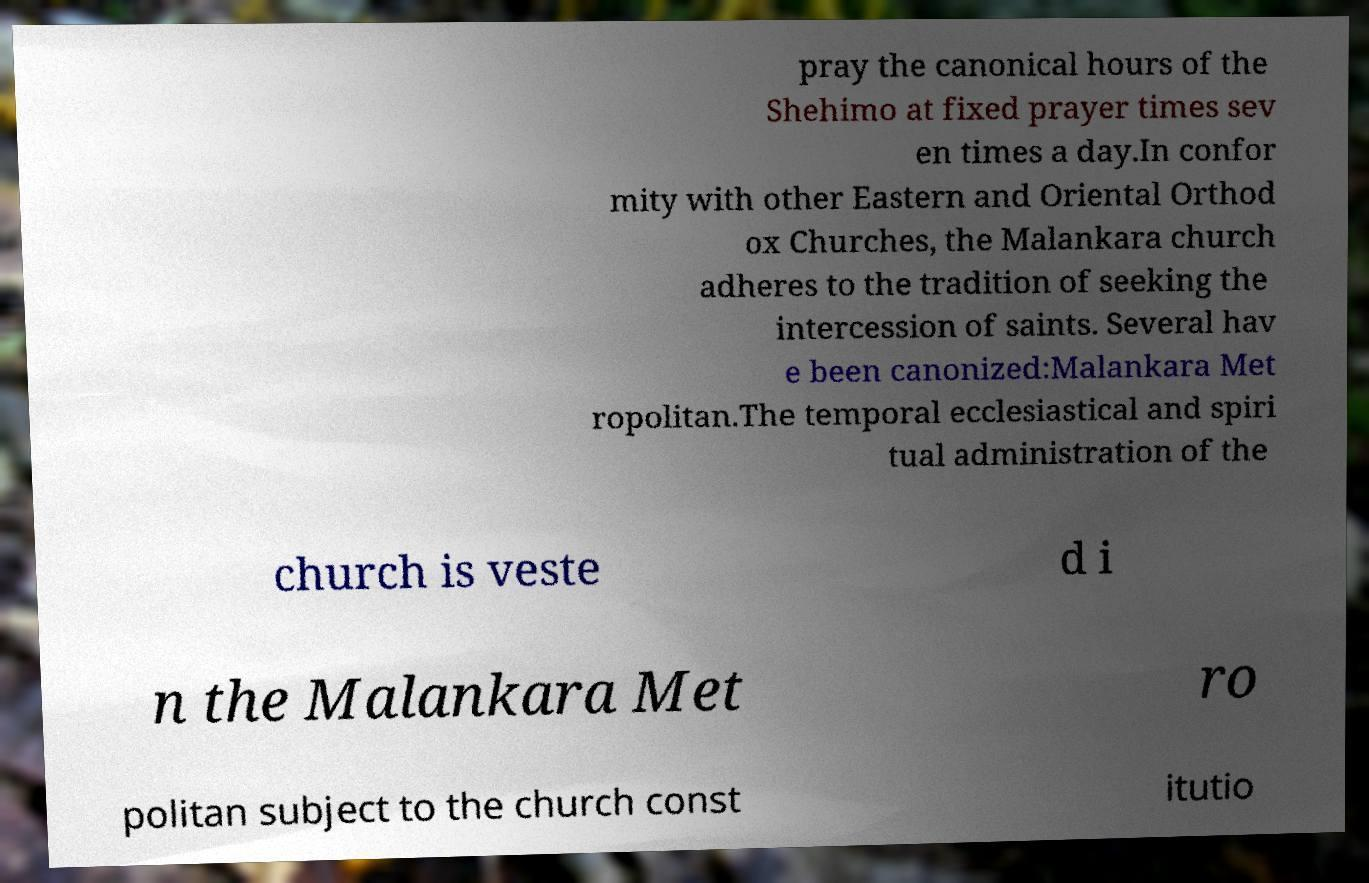Can you read and provide the text displayed in the image?This photo seems to have some interesting text. Can you extract and type it out for me? pray the canonical hours of the Shehimo at fixed prayer times sev en times a day.In confor mity with other Eastern and Oriental Orthod ox Churches, the Malankara church adheres to the tradition of seeking the intercession of saints. Several hav e been canonized:Malankara Met ropolitan.The temporal ecclesiastical and spiri tual administration of the church is veste d i n the Malankara Met ro politan subject to the church const itutio 